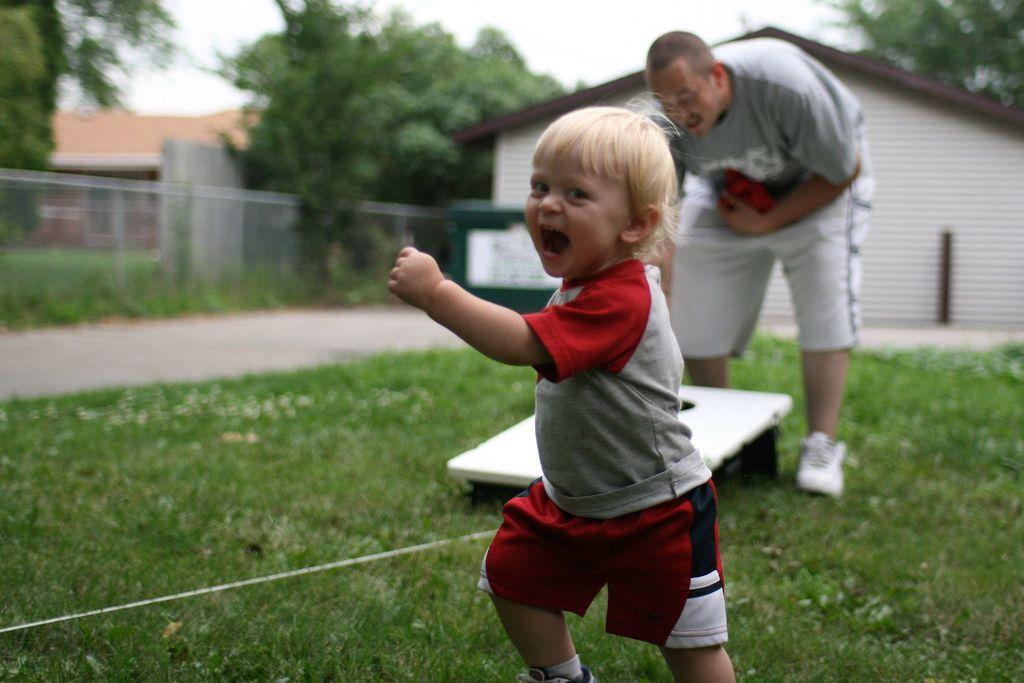Could you give a brief overview of what you see in this image? In this image, I can see a boy walking and a man standing. There is an object on the grass. In the background, there are houses, trees and fence. 